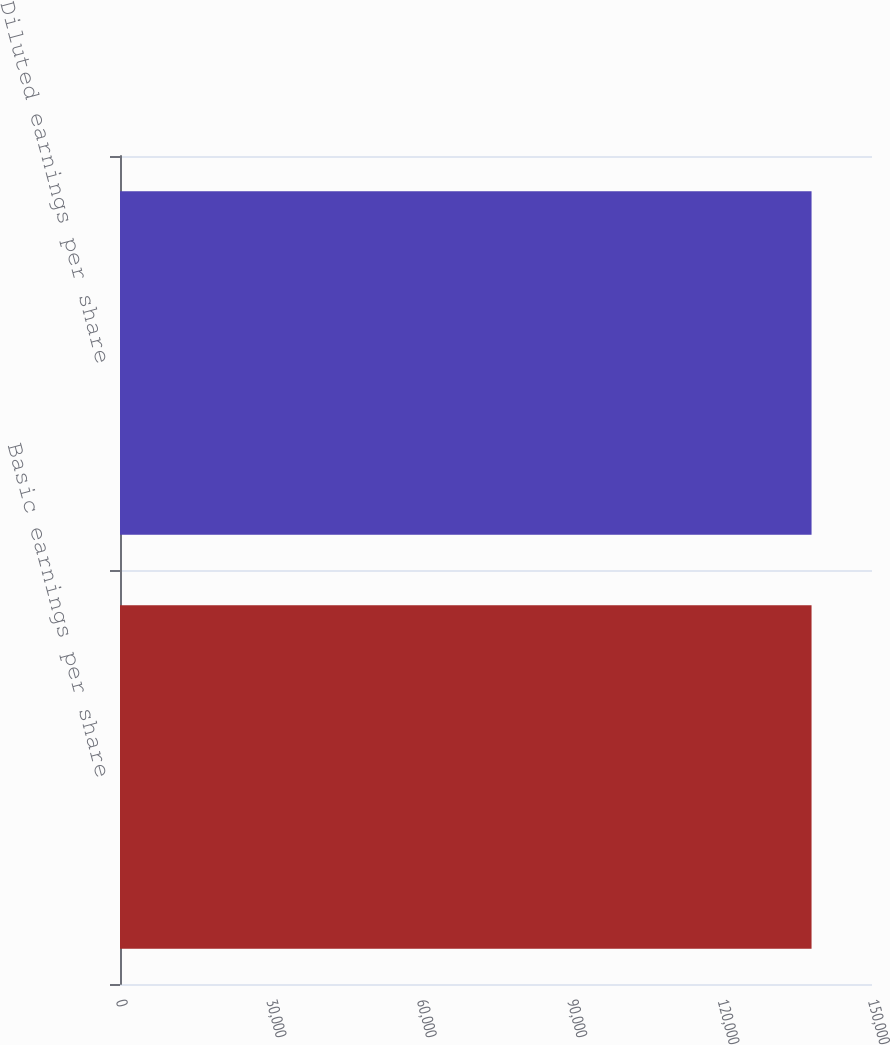Convert chart. <chart><loc_0><loc_0><loc_500><loc_500><bar_chart><fcel>Basic earnings per share<fcel>Diluted earnings per share<nl><fcel>137943<fcel>137943<nl></chart> 